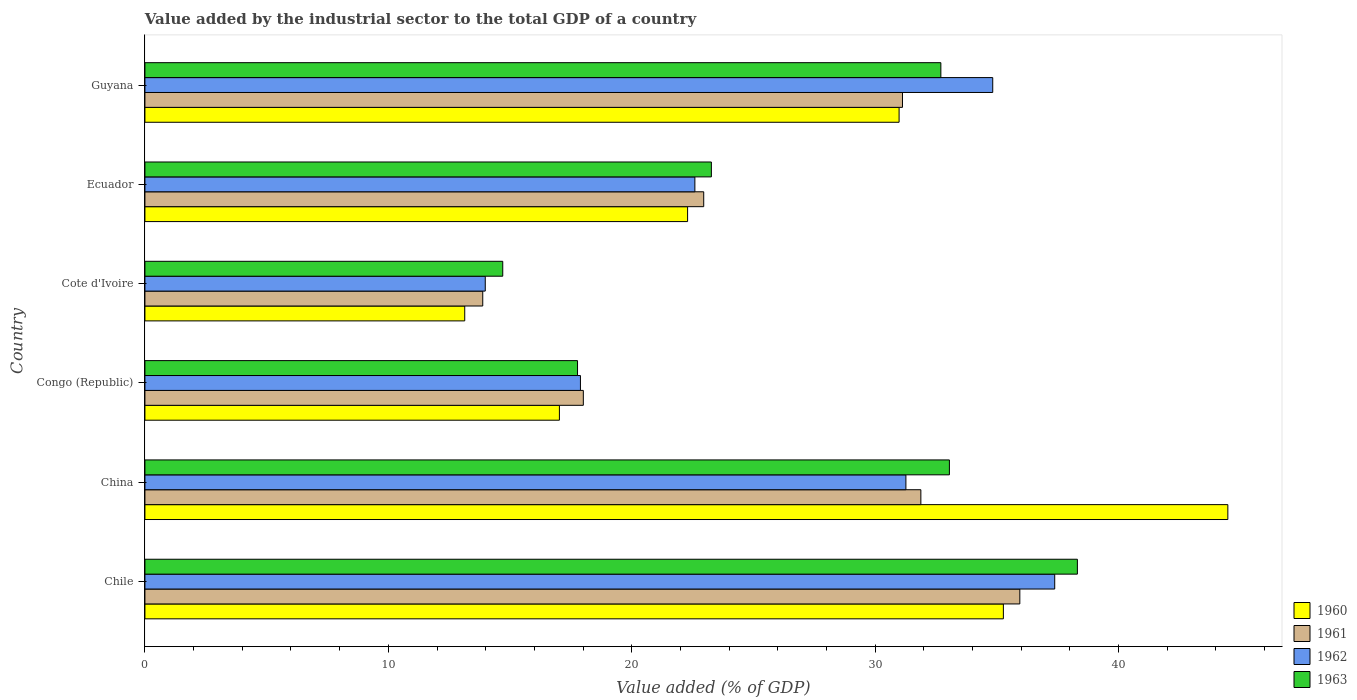How many different coloured bars are there?
Make the answer very short. 4. How many groups of bars are there?
Offer a terse response. 6. Are the number of bars on each tick of the Y-axis equal?
Provide a succinct answer. Yes. How many bars are there on the 2nd tick from the top?
Ensure brevity in your answer.  4. What is the label of the 5th group of bars from the top?
Your answer should be very brief. China. What is the value added by the industrial sector to the total GDP in 1962 in Guyana?
Your response must be concise. 34.83. Across all countries, what is the maximum value added by the industrial sector to the total GDP in 1960?
Keep it short and to the point. 44.49. Across all countries, what is the minimum value added by the industrial sector to the total GDP in 1961?
Your response must be concise. 13.88. In which country was the value added by the industrial sector to the total GDP in 1963 maximum?
Ensure brevity in your answer.  Chile. In which country was the value added by the industrial sector to the total GDP in 1962 minimum?
Your answer should be compact. Cote d'Ivoire. What is the total value added by the industrial sector to the total GDP in 1962 in the graph?
Provide a short and direct response. 157.94. What is the difference between the value added by the industrial sector to the total GDP in 1961 in Cote d'Ivoire and that in Ecuador?
Your response must be concise. -9.08. What is the difference between the value added by the industrial sector to the total GDP in 1963 in Congo (Republic) and the value added by the industrial sector to the total GDP in 1961 in China?
Make the answer very short. -14.1. What is the average value added by the industrial sector to the total GDP in 1961 per country?
Provide a succinct answer. 25.63. What is the difference between the value added by the industrial sector to the total GDP in 1960 and value added by the industrial sector to the total GDP in 1961 in Ecuador?
Provide a short and direct response. -0.66. What is the ratio of the value added by the industrial sector to the total GDP in 1961 in Cote d'Ivoire to that in Guyana?
Your answer should be very brief. 0.45. Is the value added by the industrial sector to the total GDP in 1962 in Congo (Republic) less than that in Cote d'Ivoire?
Provide a short and direct response. No. What is the difference between the highest and the second highest value added by the industrial sector to the total GDP in 1962?
Your answer should be very brief. 2.55. What is the difference between the highest and the lowest value added by the industrial sector to the total GDP in 1962?
Provide a succinct answer. 23.39. Is the sum of the value added by the industrial sector to the total GDP in 1963 in Congo (Republic) and Guyana greater than the maximum value added by the industrial sector to the total GDP in 1961 across all countries?
Offer a terse response. Yes. What does the 1st bar from the top in Cote d'Ivoire represents?
Your response must be concise. 1963. How many bars are there?
Keep it short and to the point. 24. How many countries are there in the graph?
Provide a succinct answer. 6. How many legend labels are there?
Provide a short and direct response. 4. How are the legend labels stacked?
Provide a short and direct response. Vertical. What is the title of the graph?
Your response must be concise. Value added by the industrial sector to the total GDP of a country. What is the label or title of the X-axis?
Offer a very short reply. Value added (% of GDP). What is the Value added (% of GDP) in 1960 in Chile?
Keep it short and to the point. 35.27. What is the Value added (% of GDP) of 1961 in Chile?
Provide a short and direct response. 35.94. What is the Value added (% of GDP) in 1962 in Chile?
Offer a terse response. 37.38. What is the Value added (% of GDP) in 1963 in Chile?
Offer a terse response. 38.31. What is the Value added (% of GDP) of 1960 in China?
Make the answer very short. 44.49. What is the Value added (% of GDP) of 1961 in China?
Your answer should be very brief. 31.88. What is the Value added (% of GDP) in 1962 in China?
Offer a very short reply. 31.26. What is the Value added (% of GDP) in 1963 in China?
Your response must be concise. 33.05. What is the Value added (% of GDP) of 1960 in Congo (Republic)?
Offer a very short reply. 17.03. What is the Value added (% of GDP) in 1961 in Congo (Republic)?
Provide a succinct answer. 18.01. What is the Value added (% of GDP) of 1962 in Congo (Republic)?
Provide a short and direct response. 17.89. What is the Value added (% of GDP) of 1963 in Congo (Republic)?
Offer a terse response. 17.77. What is the Value added (% of GDP) in 1960 in Cote d'Ivoire?
Your response must be concise. 13.14. What is the Value added (% of GDP) in 1961 in Cote d'Ivoire?
Your response must be concise. 13.88. What is the Value added (% of GDP) of 1962 in Cote d'Ivoire?
Your answer should be compact. 13.98. What is the Value added (% of GDP) of 1963 in Cote d'Ivoire?
Make the answer very short. 14.7. What is the Value added (% of GDP) of 1960 in Ecuador?
Your response must be concise. 22.29. What is the Value added (% of GDP) of 1961 in Ecuador?
Your response must be concise. 22.96. What is the Value added (% of GDP) in 1962 in Ecuador?
Your answer should be compact. 22.59. What is the Value added (% of GDP) of 1963 in Ecuador?
Provide a short and direct response. 23.27. What is the Value added (% of GDP) of 1960 in Guyana?
Ensure brevity in your answer.  30.98. What is the Value added (% of GDP) of 1961 in Guyana?
Provide a short and direct response. 31.12. What is the Value added (% of GDP) in 1962 in Guyana?
Offer a terse response. 34.83. What is the Value added (% of GDP) of 1963 in Guyana?
Give a very brief answer. 32.7. Across all countries, what is the maximum Value added (% of GDP) in 1960?
Your response must be concise. 44.49. Across all countries, what is the maximum Value added (% of GDP) in 1961?
Your response must be concise. 35.94. Across all countries, what is the maximum Value added (% of GDP) in 1962?
Make the answer very short. 37.38. Across all countries, what is the maximum Value added (% of GDP) of 1963?
Ensure brevity in your answer.  38.31. Across all countries, what is the minimum Value added (% of GDP) in 1960?
Ensure brevity in your answer.  13.14. Across all countries, what is the minimum Value added (% of GDP) of 1961?
Offer a very short reply. 13.88. Across all countries, what is the minimum Value added (% of GDP) of 1962?
Offer a very short reply. 13.98. Across all countries, what is the minimum Value added (% of GDP) of 1963?
Your answer should be very brief. 14.7. What is the total Value added (% of GDP) in 1960 in the graph?
Your answer should be compact. 163.2. What is the total Value added (% of GDP) in 1961 in the graph?
Your answer should be compact. 153.79. What is the total Value added (% of GDP) in 1962 in the graph?
Offer a terse response. 157.94. What is the total Value added (% of GDP) in 1963 in the graph?
Keep it short and to the point. 159.8. What is the difference between the Value added (% of GDP) in 1960 in Chile and that in China?
Your answer should be compact. -9.22. What is the difference between the Value added (% of GDP) in 1961 in Chile and that in China?
Your answer should be compact. 4.07. What is the difference between the Value added (% of GDP) of 1962 in Chile and that in China?
Make the answer very short. 6.11. What is the difference between the Value added (% of GDP) of 1963 in Chile and that in China?
Your response must be concise. 5.26. What is the difference between the Value added (% of GDP) in 1960 in Chile and that in Congo (Republic)?
Keep it short and to the point. 18.24. What is the difference between the Value added (% of GDP) in 1961 in Chile and that in Congo (Republic)?
Ensure brevity in your answer.  17.93. What is the difference between the Value added (% of GDP) of 1962 in Chile and that in Congo (Republic)?
Your response must be concise. 19.48. What is the difference between the Value added (% of GDP) of 1963 in Chile and that in Congo (Republic)?
Offer a very short reply. 20.54. What is the difference between the Value added (% of GDP) in 1960 in Chile and that in Cote d'Ivoire?
Offer a very short reply. 22.13. What is the difference between the Value added (% of GDP) in 1961 in Chile and that in Cote d'Ivoire?
Provide a succinct answer. 22.06. What is the difference between the Value added (% of GDP) of 1962 in Chile and that in Cote d'Ivoire?
Ensure brevity in your answer.  23.39. What is the difference between the Value added (% of GDP) of 1963 in Chile and that in Cote d'Ivoire?
Provide a short and direct response. 23.61. What is the difference between the Value added (% of GDP) in 1960 in Chile and that in Ecuador?
Keep it short and to the point. 12.97. What is the difference between the Value added (% of GDP) of 1961 in Chile and that in Ecuador?
Your response must be concise. 12.99. What is the difference between the Value added (% of GDP) of 1962 in Chile and that in Ecuador?
Your response must be concise. 14.78. What is the difference between the Value added (% of GDP) in 1963 in Chile and that in Ecuador?
Provide a short and direct response. 15.04. What is the difference between the Value added (% of GDP) of 1960 in Chile and that in Guyana?
Provide a short and direct response. 4.28. What is the difference between the Value added (% of GDP) in 1961 in Chile and that in Guyana?
Ensure brevity in your answer.  4.82. What is the difference between the Value added (% of GDP) in 1962 in Chile and that in Guyana?
Provide a succinct answer. 2.55. What is the difference between the Value added (% of GDP) in 1963 in Chile and that in Guyana?
Offer a very short reply. 5.61. What is the difference between the Value added (% of GDP) in 1960 in China and that in Congo (Republic)?
Your answer should be very brief. 27.46. What is the difference between the Value added (% of GDP) of 1961 in China and that in Congo (Republic)?
Keep it short and to the point. 13.87. What is the difference between the Value added (% of GDP) in 1962 in China and that in Congo (Republic)?
Your answer should be compact. 13.37. What is the difference between the Value added (% of GDP) in 1963 in China and that in Congo (Republic)?
Keep it short and to the point. 15.28. What is the difference between the Value added (% of GDP) of 1960 in China and that in Cote d'Ivoire?
Provide a short and direct response. 31.35. What is the difference between the Value added (% of GDP) in 1961 in China and that in Cote d'Ivoire?
Offer a terse response. 18. What is the difference between the Value added (% of GDP) of 1962 in China and that in Cote d'Ivoire?
Provide a short and direct response. 17.28. What is the difference between the Value added (% of GDP) of 1963 in China and that in Cote d'Ivoire?
Provide a succinct answer. 18.35. What is the difference between the Value added (% of GDP) of 1960 in China and that in Ecuador?
Give a very brief answer. 22.19. What is the difference between the Value added (% of GDP) in 1961 in China and that in Ecuador?
Ensure brevity in your answer.  8.92. What is the difference between the Value added (% of GDP) in 1962 in China and that in Ecuador?
Your answer should be compact. 8.67. What is the difference between the Value added (% of GDP) of 1963 in China and that in Ecuador?
Offer a very short reply. 9.78. What is the difference between the Value added (% of GDP) in 1960 in China and that in Guyana?
Offer a very short reply. 13.51. What is the difference between the Value added (% of GDP) in 1961 in China and that in Guyana?
Give a very brief answer. 0.76. What is the difference between the Value added (% of GDP) in 1962 in China and that in Guyana?
Ensure brevity in your answer.  -3.57. What is the difference between the Value added (% of GDP) of 1963 in China and that in Guyana?
Your response must be concise. 0.35. What is the difference between the Value added (% of GDP) of 1960 in Congo (Republic) and that in Cote d'Ivoire?
Offer a very short reply. 3.89. What is the difference between the Value added (% of GDP) of 1961 in Congo (Republic) and that in Cote d'Ivoire?
Give a very brief answer. 4.13. What is the difference between the Value added (% of GDP) in 1962 in Congo (Republic) and that in Cote d'Ivoire?
Make the answer very short. 3.91. What is the difference between the Value added (% of GDP) of 1963 in Congo (Republic) and that in Cote d'Ivoire?
Provide a succinct answer. 3.07. What is the difference between the Value added (% of GDP) in 1960 in Congo (Republic) and that in Ecuador?
Provide a short and direct response. -5.27. What is the difference between the Value added (% of GDP) of 1961 in Congo (Republic) and that in Ecuador?
Provide a short and direct response. -4.95. What is the difference between the Value added (% of GDP) of 1962 in Congo (Republic) and that in Ecuador?
Provide a succinct answer. -4.7. What is the difference between the Value added (% of GDP) in 1963 in Congo (Republic) and that in Ecuador?
Keep it short and to the point. -5.5. What is the difference between the Value added (% of GDP) of 1960 in Congo (Republic) and that in Guyana?
Offer a terse response. -13.96. What is the difference between the Value added (% of GDP) in 1961 in Congo (Republic) and that in Guyana?
Your response must be concise. -13.11. What is the difference between the Value added (% of GDP) of 1962 in Congo (Republic) and that in Guyana?
Keep it short and to the point. -16.94. What is the difference between the Value added (% of GDP) of 1963 in Congo (Republic) and that in Guyana?
Keep it short and to the point. -14.93. What is the difference between the Value added (% of GDP) of 1960 in Cote d'Ivoire and that in Ecuador?
Provide a short and direct response. -9.16. What is the difference between the Value added (% of GDP) of 1961 in Cote d'Ivoire and that in Ecuador?
Your answer should be compact. -9.08. What is the difference between the Value added (% of GDP) in 1962 in Cote d'Ivoire and that in Ecuador?
Your answer should be very brief. -8.61. What is the difference between the Value added (% of GDP) of 1963 in Cote d'Ivoire and that in Ecuador?
Offer a terse response. -8.57. What is the difference between the Value added (% of GDP) of 1960 in Cote d'Ivoire and that in Guyana?
Offer a very short reply. -17.84. What is the difference between the Value added (% of GDP) of 1961 in Cote d'Ivoire and that in Guyana?
Your response must be concise. -17.24. What is the difference between the Value added (% of GDP) of 1962 in Cote d'Ivoire and that in Guyana?
Your answer should be very brief. -20.85. What is the difference between the Value added (% of GDP) of 1963 in Cote d'Ivoire and that in Guyana?
Your response must be concise. -18. What is the difference between the Value added (% of GDP) of 1960 in Ecuador and that in Guyana?
Your answer should be compact. -8.69. What is the difference between the Value added (% of GDP) in 1961 in Ecuador and that in Guyana?
Your answer should be very brief. -8.17. What is the difference between the Value added (% of GDP) in 1962 in Ecuador and that in Guyana?
Ensure brevity in your answer.  -12.24. What is the difference between the Value added (% of GDP) of 1963 in Ecuador and that in Guyana?
Your response must be concise. -9.43. What is the difference between the Value added (% of GDP) in 1960 in Chile and the Value added (% of GDP) in 1961 in China?
Offer a very short reply. 3.39. What is the difference between the Value added (% of GDP) of 1960 in Chile and the Value added (% of GDP) of 1962 in China?
Offer a terse response. 4. What is the difference between the Value added (% of GDP) in 1960 in Chile and the Value added (% of GDP) in 1963 in China?
Offer a terse response. 2.22. What is the difference between the Value added (% of GDP) of 1961 in Chile and the Value added (% of GDP) of 1962 in China?
Your answer should be compact. 4.68. What is the difference between the Value added (% of GDP) of 1961 in Chile and the Value added (% of GDP) of 1963 in China?
Offer a terse response. 2.89. What is the difference between the Value added (% of GDP) of 1962 in Chile and the Value added (% of GDP) of 1963 in China?
Keep it short and to the point. 4.33. What is the difference between the Value added (% of GDP) in 1960 in Chile and the Value added (% of GDP) in 1961 in Congo (Republic)?
Your answer should be compact. 17.26. What is the difference between the Value added (% of GDP) of 1960 in Chile and the Value added (% of GDP) of 1962 in Congo (Republic)?
Give a very brief answer. 17.37. What is the difference between the Value added (% of GDP) of 1960 in Chile and the Value added (% of GDP) of 1963 in Congo (Republic)?
Keep it short and to the point. 17.49. What is the difference between the Value added (% of GDP) of 1961 in Chile and the Value added (% of GDP) of 1962 in Congo (Republic)?
Ensure brevity in your answer.  18.05. What is the difference between the Value added (% of GDP) in 1961 in Chile and the Value added (% of GDP) in 1963 in Congo (Republic)?
Provide a succinct answer. 18.17. What is the difference between the Value added (% of GDP) in 1962 in Chile and the Value added (% of GDP) in 1963 in Congo (Republic)?
Provide a short and direct response. 19.6. What is the difference between the Value added (% of GDP) in 1960 in Chile and the Value added (% of GDP) in 1961 in Cote d'Ivoire?
Provide a short and direct response. 21.39. What is the difference between the Value added (% of GDP) in 1960 in Chile and the Value added (% of GDP) in 1962 in Cote d'Ivoire?
Offer a very short reply. 21.28. What is the difference between the Value added (% of GDP) in 1960 in Chile and the Value added (% of GDP) in 1963 in Cote d'Ivoire?
Offer a very short reply. 20.57. What is the difference between the Value added (% of GDP) in 1961 in Chile and the Value added (% of GDP) in 1962 in Cote d'Ivoire?
Offer a very short reply. 21.96. What is the difference between the Value added (% of GDP) in 1961 in Chile and the Value added (% of GDP) in 1963 in Cote d'Ivoire?
Offer a terse response. 21.24. What is the difference between the Value added (% of GDP) of 1962 in Chile and the Value added (% of GDP) of 1963 in Cote d'Ivoire?
Ensure brevity in your answer.  22.68. What is the difference between the Value added (% of GDP) in 1960 in Chile and the Value added (% of GDP) in 1961 in Ecuador?
Offer a terse response. 12.31. What is the difference between the Value added (% of GDP) of 1960 in Chile and the Value added (% of GDP) of 1962 in Ecuador?
Offer a very short reply. 12.67. What is the difference between the Value added (% of GDP) of 1960 in Chile and the Value added (% of GDP) of 1963 in Ecuador?
Provide a short and direct response. 12. What is the difference between the Value added (% of GDP) of 1961 in Chile and the Value added (% of GDP) of 1962 in Ecuador?
Make the answer very short. 13.35. What is the difference between the Value added (% of GDP) of 1961 in Chile and the Value added (% of GDP) of 1963 in Ecuador?
Offer a terse response. 12.67. What is the difference between the Value added (% of GDP) of 1962 in Chile and the Value added (% of GDP) of 1963 in Ecuador?
Ensure brevity in your answer.  14.11. What is the difference between the Value added (% of GDP) of 1960 in Chile and the Value added (% of GDP) of 1961 in Guyana?
Provide a succinct answer. 4.14. What is the difference between the Value added (% of GDP) in 1960 in Chile and the Value added (% of GDP) in 1962 in Guyana?
Make the answer very short. 0.44. What is the difference between the Value added (% of GDP) in 1960 in Chile and the Value added (% of GDP) in 1963 in Guyana?
Your response must be concise. 2.57. What is the difference between the Value added (% of GDP) in 1961 in Chile and the Value added (% of GDP) in 1962 in Guyana?
Provide a short and direct response. 1.11. What is the difference between the Value added (% of GDP) in 1961 in Chile and the Value added (% of GDP) in 1963 in Guyana?
Ensure brevity in your answer.  3.24. What is the difference between the Value added (% of GDP) of 1962 in Chile and the Value added (% of GDP) of 1963 in Guyana?
Provide a short and direct response. 4.68. What is the difference between the Value added (% of GDP) in 1960 in China and the Value added (% of GDP) in 1961 in Congo (Republic)?
Provide a short and direct response. 26.48. What is the difference between the Value added (% of GDP) of 1960 in China and the Value added (% of GDP) of 1962 in Congo (Republic)?
Your response must be concise. 26.6. What is the difference between the Value added (% of GDP) of 1960 in China and the Value added (% of GDP) of 1963 in Congo (Republic)?
Give a very brief answer. 26.72. What is the difference between the Value added (% of GDP) of 1961 in China and the Value added (% of GDP) of 1962 in Congo (Republic)?
Your answer should be compact. 13.98. What is the difference between the Value added (% of GDP) of 1961 in China and the Value added (% of GDP) of 1963 in Congo (Republic)?
Offer a very short reply. 14.1. What is the difference between the Value added (% of GDP) in 1962 in China and the Value added (% of GDP) in 1963 in Congo (Republic)?
Your response must be concise. 13.49. What is the difference between the Value added (% of GDP) in 1960 in China and the Value added (% of GDP) in 1961 in Cote d'Ivoire?
Keep it short and to the point. 30.61. What is the difference between the Value added (% of GDP) of 1960 in China and the Value added (% of GDP) of 1962 in Cote d'Ivoire?
Provide a short and direct response. 30.51. What is the difference between the Value added (% of GDP) in 1960 in China and the Value added (% of GDP) in 1963 in Cote d'Ivoire?
Offer a very short reply. 29.79. What is the difference between the Value added (% of GDP) of 1961 in China and the Value added (% of GDP) of 1962 in Cote d'Ivoire?
Offer a terse response. 17.9. What is the difference between the Value added (% of GDP) in 1961 in China and the Value added (% of GDP) in 1963 in Cote d'Ivoire?
Your response must be concise. 17.18. What is the difference between the Value added (% of GDP) in 1962 in China and the Value added (% of GDP) in 1963 in Cote d'Ivoire?
Ensure brevity in your answer.  16.56. What is the difference between the Value added (% of GDP) of 1960 in China and the Value added (% of GDP) of 1961 in Ecuador?
Provide a succinct answer. 21.53. What is the difference between the Value added (% of GDP) of 1960 in China and the Value added (% of GDP) of 1962 in Ecuador?
Offer a terse response. 21.9. What is the difference between the Value added (% of GDP) in 1960 in China and the Value added (% of GDP) in 1963 in Ecuador?
Your answer should be very brief. 21.22. What is the difference between the Value added (% of GDP) of 1961 in China and the Value added (% of GDP) of 1962 in Ecuador?
Make the answer very short. 9.28. What is the difference between the Value added (% of GDP) of 1961 in China and the Value added (% of GDP) of 1963 in Ecuador?
Your response must be concise. 8.61. What is the difference between the Value added (% of GDP) of 1962 in China and the Value added (% of GDP) of 1963 in Ecuador?
Offer a very short reply. 7.99. What is the difference between the Value added (% of GDP) in 1960 in China and the Value added (% of GDP) in 1961 in Guyana?
Give a very brief answer. 13.37. What is the difference between the Value added (% of GDP) in 1960 in China and the Value added (% of GDP) in 1962 in Guyana?
Your response must be concise. 9.66. What is the difference between the Value added (% of GDP) in 1960 in China and the Value added (% of GDP) in 1963 in Guyana?
Make the answer very short. 11.79. What is the difference between the Value added (% of GDP) in 1961 in China and the Value added (% of GDP) in 1962 in Guyana?
Provide a succinct answer. -2.95. What is the difference between the Value added (% of GDP) in 1961 in China and the Value added (% of GDP) in 1963 in Guyana?
Make the answer very short. -0.82. What is the difference between the Value added (% of GDP) of 1962 in China and the Value added (% of GDP) of 1963 in Guyana?
Your response must be concise. -1.44. What is the difference between the Value added (% of GDP) of 1960 in Congo (Republic) and the Value added (% of GDP) of 1961 in Cote d'Ivoire?
Your response must be concise. 3.15. What is the difference between the Value added (% of GDP) in 1960 in Congo (Republic) and the Value added (% of GDP) in 1962 in Cote d'Ivoire?
Provide a succinct answer. 3.05. What is the difference between the Value added (% of GDP) of 1960 in Congo (Republic) and the Value added (% of GDP) of 1963 in Cote d'Ivoire?
Keep it short and to the point. 2.33. What is the difference between the Value added (% of GDP) in 1961 in Congo (Republic) and the Value added (% of GDP) in 1962 in Cote d'Ivoire?
Offer a terse response. 4.03. What is the difference between the Value added (% of GDP) in 1961 in Congo (Republic) and the Value added (% of GDP) in 1963 in Cote d'Ivoire?
Make the answer very short. 3.31. What is the difference between the Value added (% of GDP) of 1962 in Congo (Republic) and the Value added (% of GDP) of 1963 in Cote d'Ivoire?
Keep it short and to the point. 3.19. What is the difference between the Value added (% of GDP) of 1960 in Congo (Republic) and the Value added (% of GDP) of 1961 in Ecuador?
Make the answer very short. -5.93. What is the difference between the Value added (% of GDP) of 1960 in Congo (Republic) and the Value added (% of GDP) of 1962 in Ecuador?
Give a very brief answer. -5.57. What is the difference between the Value added (% of GDP) in 1960 in Congo (Republic) and the Value added (% of GDP) in 1963 in Ecuador?
Offer a very short reply. -6.24. What is the difference between the Value added (% of GDP) in 1961 in Congo (Republic) and the Value added (% of GDP) in 1962 in Ecuador?
Offer a terse response. -4.58. What is the difference between the Value added (% of GDP) of 1961 in Congo (Republic) and the Value added (% of GDP) of 1963 in Ecuador?
Keep it short and to the point. -5.26. What is the difference between the Value added (% of GDP) in 1962 in Congo (Republic) and the Value added (% of GDP) in 1963 in Ecuador?
Your answer should be compact. -5.38. What is the difference between the Value added (% of GDP) in 1960 in Congo (Republic) and the Value added (% of GDP) in 1961 in Guyana?
Provide a short and direct response. -14.09. What is the difference between the Value added (% of GDP) in 1960 in Congo (Republic) and the Value added (% of GDP) in 1962 in Guyana?
Ensure brevity in your answer.  -17.8. What is the difference between the Value added (% of GDP) of 1960 in Congo (Republic) and the Value added (% of GDP) of 1963 in Guyana?
Give a very brief answer. -15.67. What is the difference between the Value added (% of GDP) in 1961 in Congo (Republic) and the Value added (% of GDP) in 1962 in Guyana?
Offer a very short reply. -16.82. What is the difference between the Value added (% of GDP) of 1961 in Congo (Republic) and the Value added (% of GDP) of 1963 in Guyana?
Provide a short and direct response. -14.69. What is the difference between the Value added (% of GDP) in 1962 in Congo (Republic) and the Value added (% of GDP) in 1963 in Guyana?
Make the answer very short. -14.81. What is the difference between the Value added (% of GDP) of 1960 in Cote d'Ivoire and the Value added (% of GDP) of 1961 in Ecuador?
Offer a terse response. -9.82. What is the difference between the Value added (% of GDP) in 1960 in Cote d'Ivoire and the Value added (% of GDP) in 1962 in Ecuador?
Your answer should be very brief. -9.45. What is the difference between the Value added (% of GDP) of 1960 in Cote d'Ivoire and the Value added (% of GDP) of 1963 in Ecuador?
Make the answer very short. -10.13. What is the difference between the Value added (% of GDP) of 1961 in Cote d'Ivoire and the Value added (% of GDP) of 1962 in Ecuador?
Ensure brevity in your answer.  -8.71. What is the difference between the Value added (% of GDP) of 1961 in Cote d'Ivoire and the Value added (% of GDP) of 1963 in Ecuador?
Keep it short and to the point. -9.39. What is the difference between the Value added (% of GDP) of 1962 in Cote d'Ivoire and the Value added (% of GDP) of 1963 in Ecuador?
Your answer should be compact. -9.29. What is the difference between the Value added (% of GDP) of 1960 in Cote d'Ivoire and the Value added (% of GDP) of 1961 in Guyana?
Provide a succinct answer. -17.98. What is the difference between the Value added (% of GDP) of 1960 in Cote d'Ivoire and the Value added (% of GDP) of 1962 in Guyana?
Offer a very short reply. -21.69. What is the difference between the Value added (% of GDP) of 1960 in Cote d'Ivoire and the Value added (% of GDP) of 1963 in Guyana?
Provide a succinct answer. -19.56. What is the difference between the Value added (% of GDP) in 1961 in Cote d'Ivoire and the Value added (% of GDP) in 1962 in Guyana?
Give a very brief answer. -20.95. What is the difference between the Value added (% of GDP) of 1961 in Cote d'Ivoire and the Value added (% of GDP) of 1963 in Guyana?
Make the answer very short. -18.82. What is the difference between the Value added (% of GDP) in 1962 in Cote d'Ivoire and the Value added (% of GDP) in 1963 in Guyana?
Offer a terse response. -18.72. What is the difference between the Value added (% of GDP) of 1960 in Ecuador and the Value added (% of GDP) of 1961 in Guyana?
Ensure brevity in your answer.  -8.83. What is the difference between the Value added (% of GDP) of 1960 in Ecuador and the Value added (% of GDP) of 1962 in Guyana?
Your answer should be very brief. -12.54. What is the difference between the Value added (% of GDP) in 1960 in Ecuador and the Value added (% of GDP) in 1963 in Guyana?
Offer a terse response. -10.4. What is the difference between the Value added (% of GDP) in 1961 in Ecuador and the Value added (% of GDP) in 1962 in Guyana?
Provide a succinct answer. -11.87. What is the difference between the Value added (% of GDP) in 1961 in Ecuador and the Value added (% of GDP) in 1963 in Guyana?
Your answer should be compact. -9.74. What is the difference between the Value added (% of GDP) of 1962 in Ecuador and the Value added (% of GDP) of 1963 in Guyana?
Offer a very short reply. -10.11. What is the average Value added (% of GDP) of 1960 per country?
Keep it short and to the point. 27.2. What is the average Value added (% of GDP) of 1961 per country?
Provide a succinct answer. 25.63. What is the average Value added (% of GDP) of 1962 per country?
Keep it short and to the point. 26.32. What is the average Value added (% of GDP) in 1963 per country?
Your answer should be very brief. 26.63. What is the difference between the Value added (% of GDP) of 1960 and Value added (% of GDP) of 1961 in Chile?
Provide a succinct answer. -0.68. What is the difference between the Value added (% of GDP) of 1960 and Value added (% of GDP) of 1962 in Chile?
Provide a succinct answer. -2.11. What is the difference between the Value added (% of GDP) in 1960 and Value added (% of GDP) in 1963 in Chile?
Offer a terse response. -3.04. What is the difference between the Value added (% of GDP) in 1961 and Value added (% of GDP) in 1962 in Chile?
Provide a short and direct response. -1.43. What is the difference between the Value added (% of GDP) in 1961 and Value added (% of GDP) in 1963 in Chile?
Offer a terse response. -2.36. What is the difference between the Value added (% of GDP) of 1962 and Value added (% of GDP) of 1963 in Chile?
Provide a succinct answer. -0.93. What is the difference between the Value added (% of GDP) of 1960 and Value added (% of GDP) of 1961 in China?
Provide a succinct answer. 12.61. What is the difference between the Value added (% of GDP) of 1960 and Value added (% of GDP) of 1962 in China?
Offer a terse response. 13.23. What is the difference between the Value added (% of GDP) of 1960 and Value added (% of GDP) of 1963 in China?
Provide a succinct answer. 11.44. What is the difference between the Value added (% of GDP) in 1961 and Value added (% of GDP) in 1962 in China?
Offer a terse response. 0.61. What is the difference between the Value added (% of GDP) in 1961 and Value added (% of GDP) in 1963 in China?
Your response must be concise. -1.17. What is the difference between the Value added (% of GDP) of 1962 and Value added (% of GDP) of 1963 in China?
Offer a terse response. -1.79. What is the difference between the Value added (% of GDP) in 1960 and Value added (% of GDP) in 1961 in Congo (Republic)?
Offer a very short reply. -0.98. What is the difference between the Value added (% of GDP) of 1960 and Value added (% of GDP) of 1962 in Congo (Republic)?
Your response must be concise. -0.86. What is the difference between the Value added (% of GDP) in 1960 and Value added (% of GDP) in 1963 in Congo (Republic)?
Your answer should be very brief. -0.74. What is the difference between the Value added (% of GDP) of 1961 and Value added (% of GDP) of 1962 in Congo (Republic)?
Provide a short and direct response. 0.12. What is the difference between the Value added (% of GDP) of 1961 and Value added (% of GDP) of 1963 in Congo (Republic)?
Your response must be concise. 0.24. What is the difference between the Value added (% of GDP) in 1962 and Value added (% of GDP) in 1963 in Congo (Republic)?
Your response must be concise. 0.12. What is the difference between the Value added (% of GDP) in 1960 and Value added (% of GDP) in 1961 in Cote d'Ivoire?
Your answer should be very brief. -0.74. What is the difference between the Value added (% of GDP) of 1960 and Value added (% of GDP) of 1962 in Cote d'Ivoire?
Your answer should be very brief. -0.84. What is the difference between the Value added (% of GDP) of 1960 and Value added (% of GDP) of 1963 in Cote d'Ivoire?
Ensure brevity in your answer.  -1.56. What is the difference between the Value added (% of GDP) in 1961 and Value added (% of GDP) in 1962 in Cote d'Ivoire?
Offer a very short reply. -0.1. What is the difference between the Value added (% of GDP) in 1961 and Value added (% of GDP) in 1963 in Cote d'Ivoire?
Make the answer very short. -0.82. What is the difference between the Value added (% of GDP) in 1962 and Value added (% of GDP) in 1963 in Cote d'Ivoire?
Provide a succinct answer. -0.72. What is the difference between the Value added (% of GDP) in 1960 and Value added (% of GDP) in 1961 in Ecuador?
Ensure brevity in your answer.  -0.66. What is the difference between the Value added (% of GDP) of 1960 and Value added (% of GDP) of 1962 in Ecuador?
Provide a succinct answer. -0.3. What is the difference between the Value added (% of GDP) in 1960 and Value added (% of GDP) in 1963 in Ecuador?
Give a very brief answer. -0.98. What is the difference between the Value added (% of GDP) of 1961 and Value added (% of GDP) of 1962 in Ecuador?
Your answer should be very brief. 0.36. What is the difference between the Value added (% of GDP) in 1961 and Value added (% of GDP) in 1963 in Ecuador?
Your answer should be compact. -0.31. What is the difference between the Value added (% of GDP) in 1962 and Value added (% of GDP) in 1963 in Ecuador?
Offer a terse response. -0.68. What is the difference between the Value added (% of GDP) of 1960 and Value added (% of GDP) of 1961 in Guyana?
Make the answer very short. -0.14. What is the difference between the Value added (% of GDP) of 1960 and Value added (% of GDP) of 1962 in Guyana?
Provide a short and direct response. -3.85. What is the difference between the Value added (% of GDP) of 1960 and Value added (% of GDP) of 1963 in Guyana?
Your response must be concise. -1.72. What is the difference between the Value added (% of GDP) of 1961 and Value added (% of GDP) of 1962 in Guyana?
Keep it short and to the point. -3.71. What is the difference between the Value added (% of GDP) in 1961 and Value added (% of GDP) in 1963 in Guyana?
Provide a succinct answer. -1.58. What is the difference between the Value added (% of GDP) of 1962 and Value added (% of GDP) of 1963 in Guyana?
Ensure brevity in your answer.  2.13. What is the ratio of the Value added (% of GDP) in 1960 in Chile to that in China?
Your answer should be compact. 0.79. What is the ratio of the Value added (% of GDP) of 1961 in Chile to that in China?
Offer a terse response. 1.13. What is the ratio of the Value added (% of GDP) of 1962 in Chile to that in China?
Your response must be concise. 1.2. What is the ratio of the Value added (% of GDP) of 1963 in Chile to that in China?
Give a very brief answer. 1.16. What is the ratio of the Value added (% of GDP) of 1960 in Chile to that in Congo (Republic)?
Provide a succinct answer. 2.07. What is the ratio of the Value added (% of GDP) in 1961 in Chile to that in Congo (Republic)?
Offer a very short reply. 2. What is the ratio of the Value added (% of GDP) in 1962 in Chile to that in Congo (Republic)?
Your response must be concise. 2.09. What is the ratio of the Value added (% of GDP) in 1963 in Chile to that in Congo (Republic)?
Make the answer very short. 2.16. What is the ratio of the Value added (% of GDP) in 1960 in Chile to that in Cote d'Ivoire?
Ensure brevity in your answer.  2.68. What is the ratio of the Value added (% of GDP) of 1961 in Chile to that in Cote d'Ivoire?
Provide a succinct answer. 2.59. What is the ratio of the Value added (% of GDP) in 1962 in Chile to that in Cote d'Ivoire?
Give a very brief answer. 2.67. What is the ratio of the Value added (% of GDP) of 1963 in Chile to that in Cote d'Ivoire?
Offer a terse response. 2.61. What is the ratio of the Value added (% of GDP) in 1960 in Chile to that in Ecuador?
Provide a short and direct response. 1.58. What is the ratio of the Value added (% of GDP) of 1961 in Chile to that in Ecuador?
Your answer should be very brief. 1.57. What is the ratio of the Value added (% of GDP) of 1962 in Chile to that in Ecuador?
Offer a terse response. 1.65. What is the ratio of the Value added (% of GDP) of 1963 in Chile to that in Ecuador?
Provide a short and direct response. 1.65. What is the ratio of the Value added (% of GDP) of 1960 in Chile to that in Guyana?
Your answer should be compact. 1.14. What is the ratio of the Value added (% of GDP) in 1961 in Chile to that in Guyana?
Offer a very short reply. 1.15. What is the ratio of the Value added (% of GDP) of 1962 in Chile to that in Guyana?
Ensure brevity in your answer.  1.07. What is the ratio of the Value added (% of GDP) of 1963 in Chile to that in Guyana?
Your answer should be very brief. 1.17. What is the ratio of the Value added (% of GDP) in 1960 in China to that in Congo (Republic)?
Your response must be concise. 2.61. What is the ratio of the Value added (% of GDP) of 1961 in China to that in Congo (Republic)?
Your response must be concise. 1.77. What is the ratio of the Value added (% of GDP) in 1962 in China to that in Congo (Republic)?
Offer a very short reply. 1.75. What is the ratio of the Value added (% of GDP) in 1963 in China to that in Congo (Republic)?
Your response must be concise. 1.86. What is the ratio of the Value added (% of GDP) of 1960 in China to that in Cote d'Ivoire?
Your answer should be very brief. 3.39. What is the ratio of the Value added (% of GDP) in 1961 in China to that in Cote d'Ivoire?
Your answer should be very brief. 2.3. What is the ratio of the Value added (% of GDP) in 1962 in China to that in Cote d'Ivoire?
Provide a short and direct response. 2.24. What is the ratio of the Value added (% of GDP) in 1963 in China to that in Cote d'Ivoire?
Provide a succinct answer. 2.25. What is the ratio of the Value added (% of GDP) of 1960 in China to that in Ecuador?
Give a very brief answer. 2. What is the ratio of the Value added (% of GDP) in 1961 in China to that in Ecuador?
Offer a terse response. 1.39. What is the ratio of the Value added (% of GDP) of 1962 in China to that in Ecuador?
Offer a terse response. 1.38. What is the ratio of the Value added (% of GDP) in 1963 in China to that in Ecuador?
Your answer should be very brief. 1.42. What is the ratio of the Value added (% of GDP) in 1960 in China to that in Guyana?
Give a very brief answer. 1.44. What is the ratio of the Value added (% of GDP) of 1961 in China to that in Guyana?
Keep it short and to the point. 1.02. What is the ratio of the Value added (% of GDP) of 1962 in China to that in Guyana?
Offer a terse response. 0.9. What is the ratio of the Value added (% of GDP) of 1963 in China to that in Guyana?
Offer a terse response. 1.01. What is the ratio of the Value added (% of GDP) of 1960 in Congo (Republic) to that in Cote d'Ivoire?
Your answer should be very brief. 1.3. What is the ratio of the Value added (% of GDP) in 1961 in Congo (Republic) to that in Cote d'Ivoire?
Your answer should be compact. 1.3. What is the ratio of the Value added (% of GDP) of 1962 in Congo (Republic) to that in Cote d'Ivoire?
Make the answer very short. 1.28. What is the ratio of the Value added (% of GDP) in 1963 in Congo (Republic) to that in Cote d'Ivoire?
Provide a succinct answer. 1.21. What is the ratio of the Value added (% of GDP) in 1960 in Congo (Republic) to that in Ecuador?
Offer a terse response. 0.76. What is the ratio of the Value added (% of GDP) of 1961 in Congo (Republic) to that in Ecuador?
Your response must be concise. 0.78. What is the ratio of the Value added (% of GDP) in 1962 in Congo (Republic) to that in Ecuador?
Make the answer very short. 0.79. What is the ratio of the Value added (% of GDP) in 1963 in Congo (Republic) to that in Ecuador?
Give a very brief answer. 0.76. What is the ratio of the Value added (% of GDP) in 1960 in Congo (Republic) to that in Guyana?
Offer a very short reply. 0.55. What is the ratio of the Value added (% of GDP) in 1961 in Congo (Republic) to that in Guyana?
Your response must be concise. 0.58. What is the ratio of the Value added (% of GDP) of 1962 in Congo (Republic) to that in Guyana?
Offer a terse response. 0.51. What is the ratio of the Value added (% of GDP) in 1963 in Congo (Republic) to that in Guyana?
Ensure brevity in your answer.  0.54. What is the ratio of the Value added (% of GDP) of 1960 in Cote d'Ivoire to that in Ecuador?
Make the answer very short. 0.59. What is the ratio of the Value added (% of GDP) in 1961 in Cote d'Ivoire to that in Ecuador?
Keep it short and to the point. 0.6. What is the ratio of the Value added (% of GDP) in 1962 in Cote d'Ivoire to that in Ecuador?
Ensure brevity in your answer.  0.62. What is the ratio of the Value added (% of GDP) of 1963 in Cote d'Ivoire to that in Ecuador?
Make the answer very short. 0.63. What is the ratio of the Value added (% of GDP) in 1960 in Cote d'Ivoire to that in Guyana?
Your answer should be very brief. 0.42. What is the ratio of the Value added (% of GDP) of 1961 in Cote d'Ivoire to that in Guyana?
Your answer should be very brief. 0.45. What is the ratio of the Value added (% of GDP) of 1962 in Cote d'Ivoire to that in Guyana?
Ensure brevity in your answer.  0.4. What is the ratio of the Value added (% of GDP) in 1963 in Cote d'Ivoire to that in Guyana?
Keep it short and to the point. 0.45. What is the ratio of the Value added (% of GDP) of 1960 in Ecuador to that in Guyana?
Keep it short and to the point. 0.72. What is the ratio of the Value added (% of GDP) of 1961 in Ecuador to that in Guyana?
Your answer should be compact. 0.74. What is the ratio of the Value added (% of GDP) of 1962 in Ecuador to that in Guyana?
Ensure brevity in your answer.  0.65. What is the ratio of the Value added (% of GDP) in 1963 in Ecuador to that in Guyana?
Provide a short and direct response. 0.71. What is the difference between the highest and the second highest Value added (% of GDP) of 1960?
Your answer should be compact. 9.22. What is the difference between the highest and the second highest Value added (% of GDP) of 1961?
Your answer should be compact. 4.07. What is the difference between the highest and the second highest Value added (% of GDP) of 1962?
Make the answer very short. 2.55. What is the difference between the highest and the second highest Value added (% of GDP) in 1963?
Keep it short and to the point. 5.26. What is the difference between the highest and the lowest Value added (% of GDP) of 1960?
Offer a very short reply. 31.35. What is the difference between the highest and the lowest Value added (% of GDP) of 1961?
Your response must be concise. 22.06. What is the difference between the highest and the lowest Value added (% of GDP) of 1962?
Offer a terse response. 23.39. What is the difference between the highest and the lowest Value added (% of GDP) in 1963?
Offer a very short reply. 23.61. 